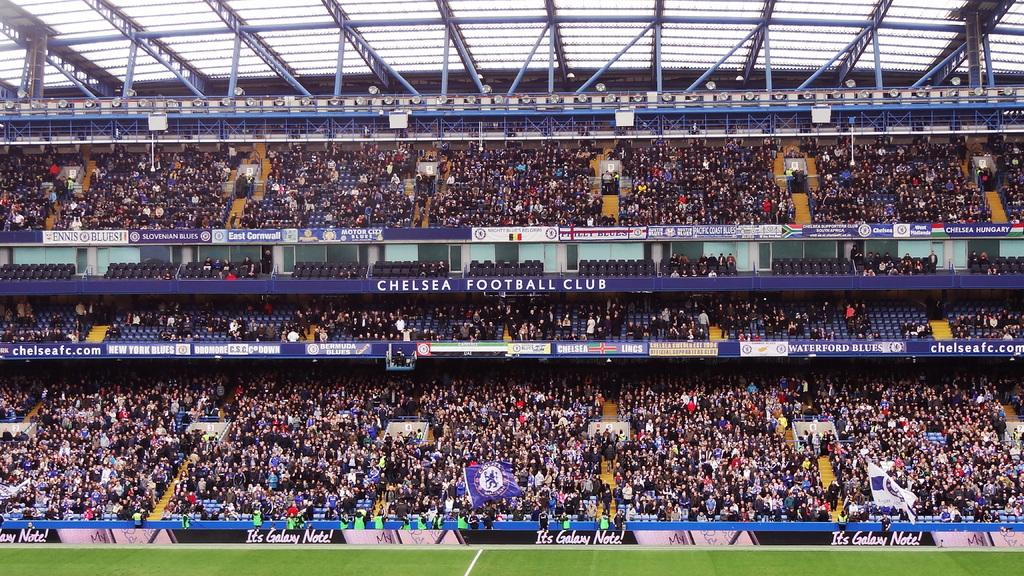<image>
Write a terse but informative summary of the picture. a stadium for soccer that belongs to Chelsea 